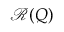<formula> <loc_0><loc_0><loc_500><loc_500>\mathcal { R } ( Q )</formula> 